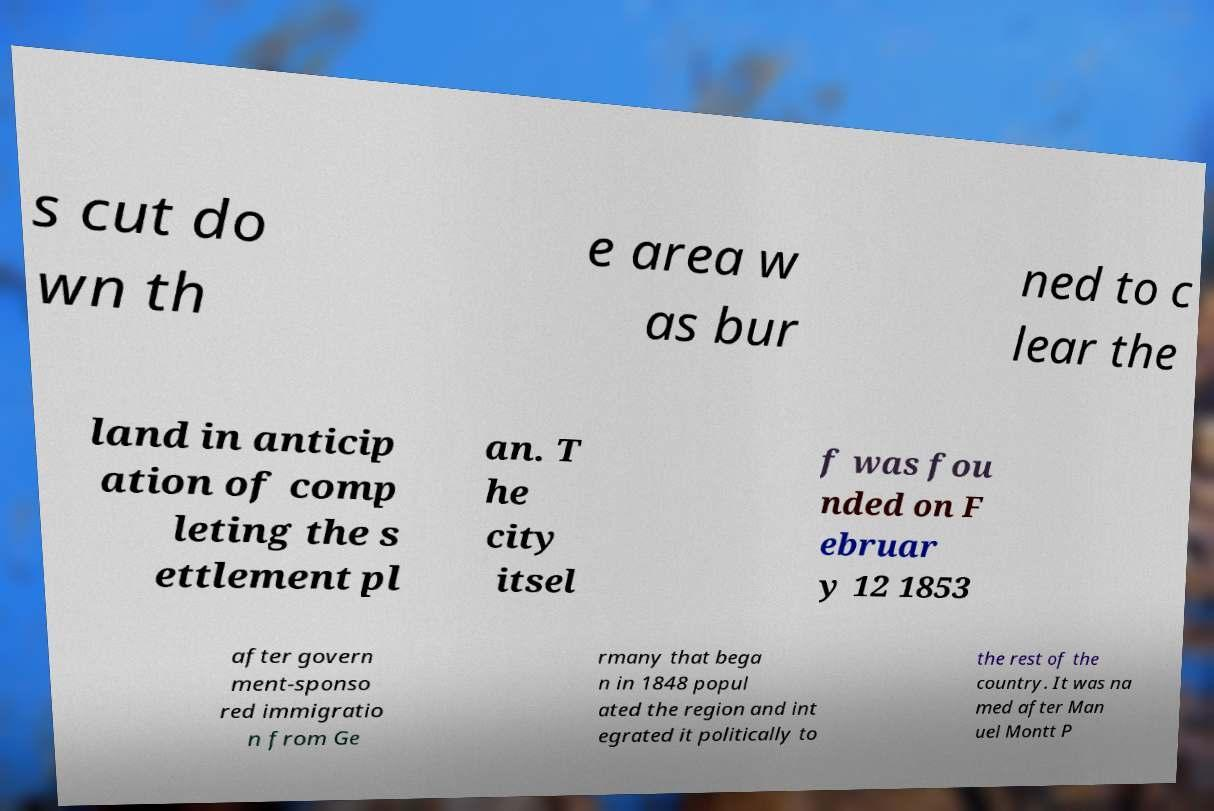Can you accurately transcribe the text from the provided image for me? s cut do wn th e area w as bur ned to c lear the land in anticip ation of comp leting the s ettlement pl an. T he city itsel f was fou nded on F ebruar y 12 1853 after govern ment-sponso red immigratio n from Ge rmany that bega n in 1848 popul ated the region and int egrated it politically to the rest of the country. It was na med after Man uel Montt P 